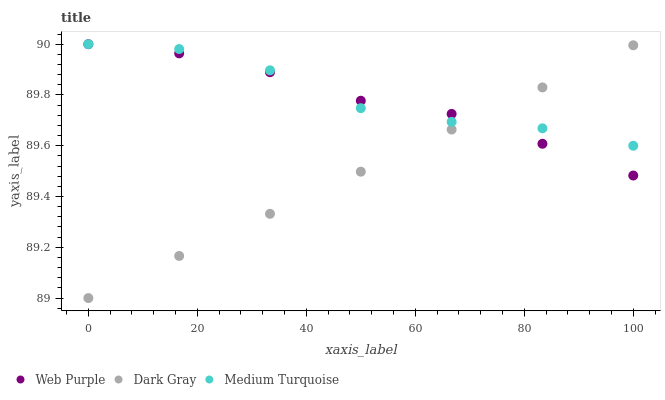Does Dark Gray have the minimum area under the curve?
Answer yes or no. Yes. Does Medium Turquoise have the maximum area under the curve?
Answer yes or no. Yes. Does Web Purple have the minimum area under the curve?
Answer yes or no. No. Does Web Purple have the maximum area under the curve?
Answer yes or no. No. Is Dark Gray the smoothest?
Answer yes or no. Yes. Is Medium Turquoise the roughest?
Answer yes or no. Yes. Is Web Purple the smoothest?
Answer yes or no. No. Is Web Purple the roughest?
Answer yes or no. No. Does Dark Gray have the lowest value?
Answer yes or no. Yes. Does Web Purple have the lowest value?
Answer yes or no. No. Does Medium Turquoise have the highest value?
Answer yes or no. Yes. Does Medium Turquoise intersect Dark Gray?
Answer yes or no. Yes. Is Medium Turquoise less than Dark Gray?
Answer yes or no. No. Is Medium Turquoise greater than Dark Gray?
Answer yes or no. No. 